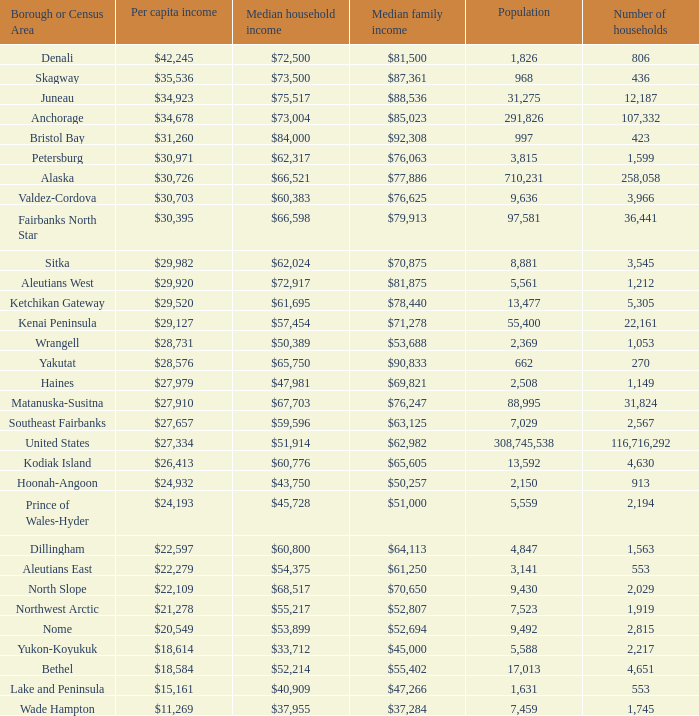What is the population of the locality with a median family income of $71,278? 1.0. 